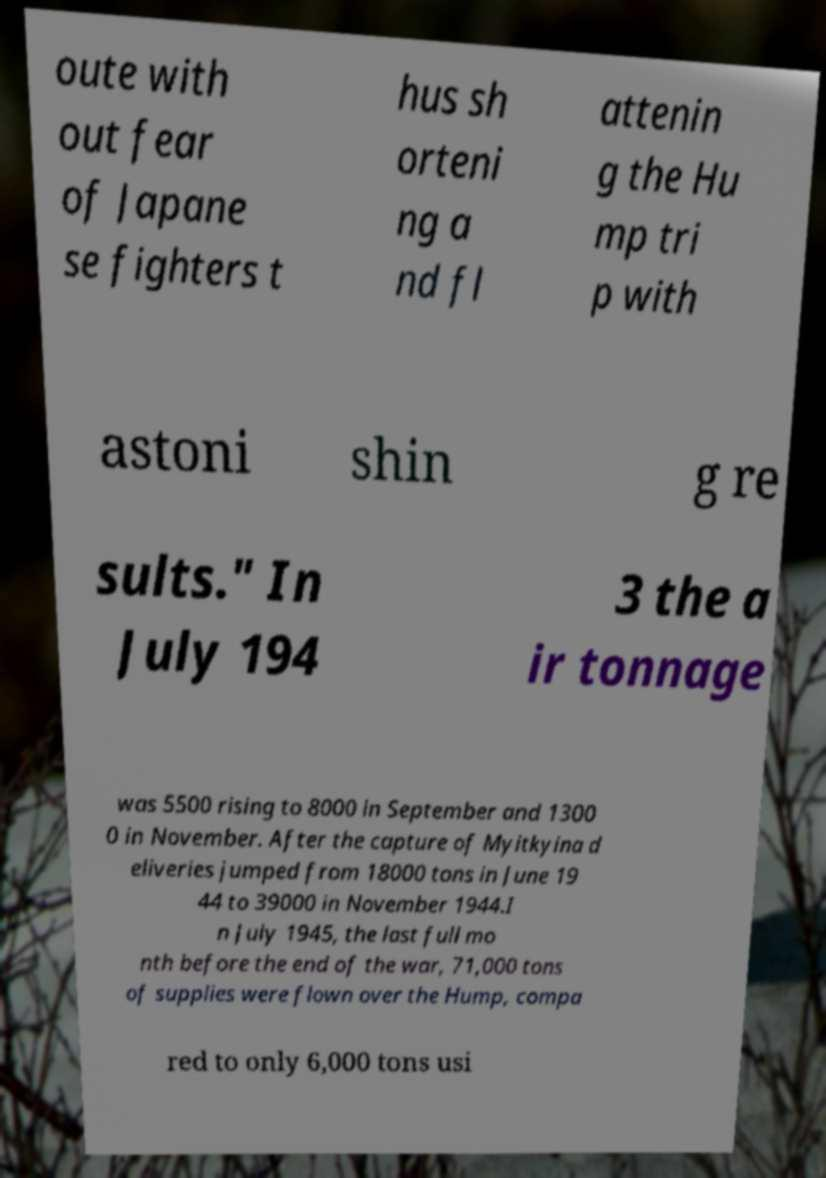Please identify and transcribe the text found in this image. oute with out fear of Japane se fighters t hus sh orteni ng a nd fl attenin g the Hu mp tri p with astoni shin g re sults." In July 194 3 the a ir tonnage was 5500 rising to 8000 in September and 1300 0 in November. After the capture of Myitkyina d eliveries jumped from 18000 tons in June 19 44 to 39000 in November 1944.I n July 1945, the last full mo nth before the end of the war, 71,000 tons of supplies were flown over the Hump, compa red to only 6,000 tons usi 